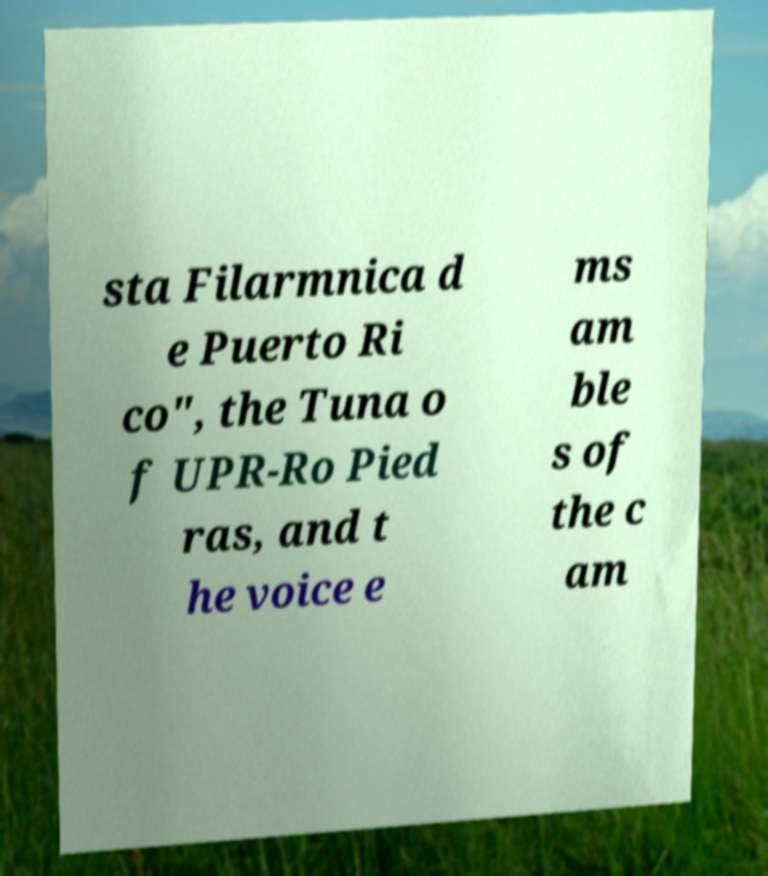Could you extract and type out the text from this image? sta Filarmnica d e Puerto Ri co", the Tuna o f UPR-Ro Pied ras, and t he voice e ms am ble s of the c am 